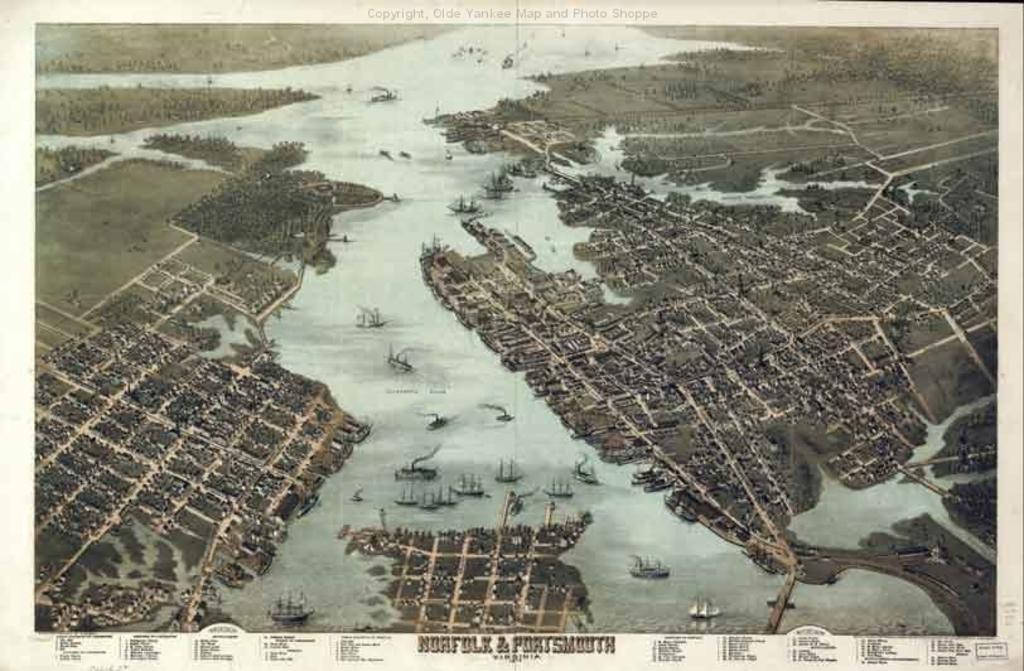Please provide a concise description of this image. This image is a poster. In this image we can see trees, water, boats. At the bottom of the image there is some text. 